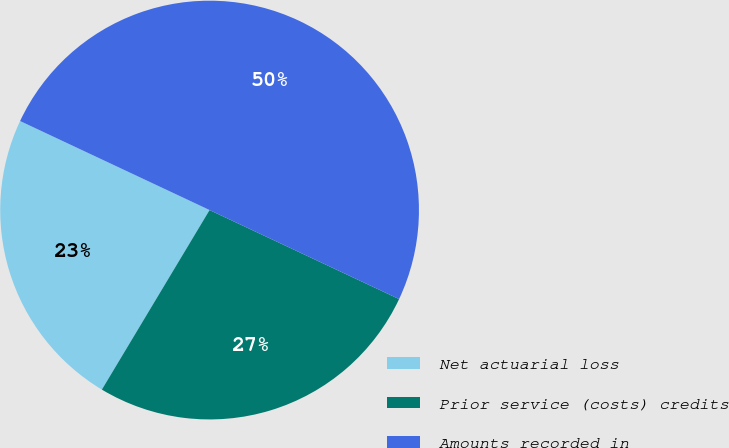Convert chart to OTSL. <chart><loc_0><loc_0><loc_500><loc_500><pie_chart><fcel>Net actuarial loss<fcel>Prior service (costs) credits<fcel>Amounts recorded in<nl><fcel>23.39%<fcel>26.61%<fcel>50.0%<nl></chart> 